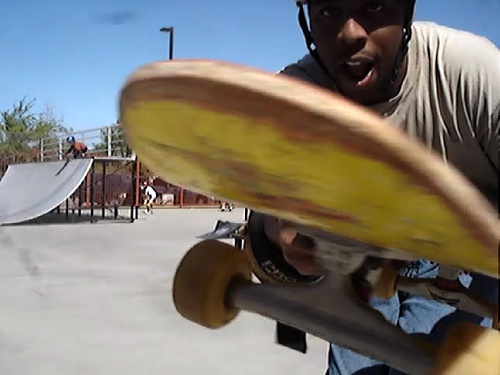Describe the objects in this image and their specific colors. I can see skateboard in gray, black, olive, and maroon tones, people in gray, black, lightgray, and darkgray tones, people in gray, white, black, and darkgray tones, people in gray, black, brown, and maroon tones, and people in gray, pink, and lightgray tones in this image. 